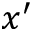<formula> <loc_0><loc_0><loc_500><loc_500>x ^ { \prime }</formula> 